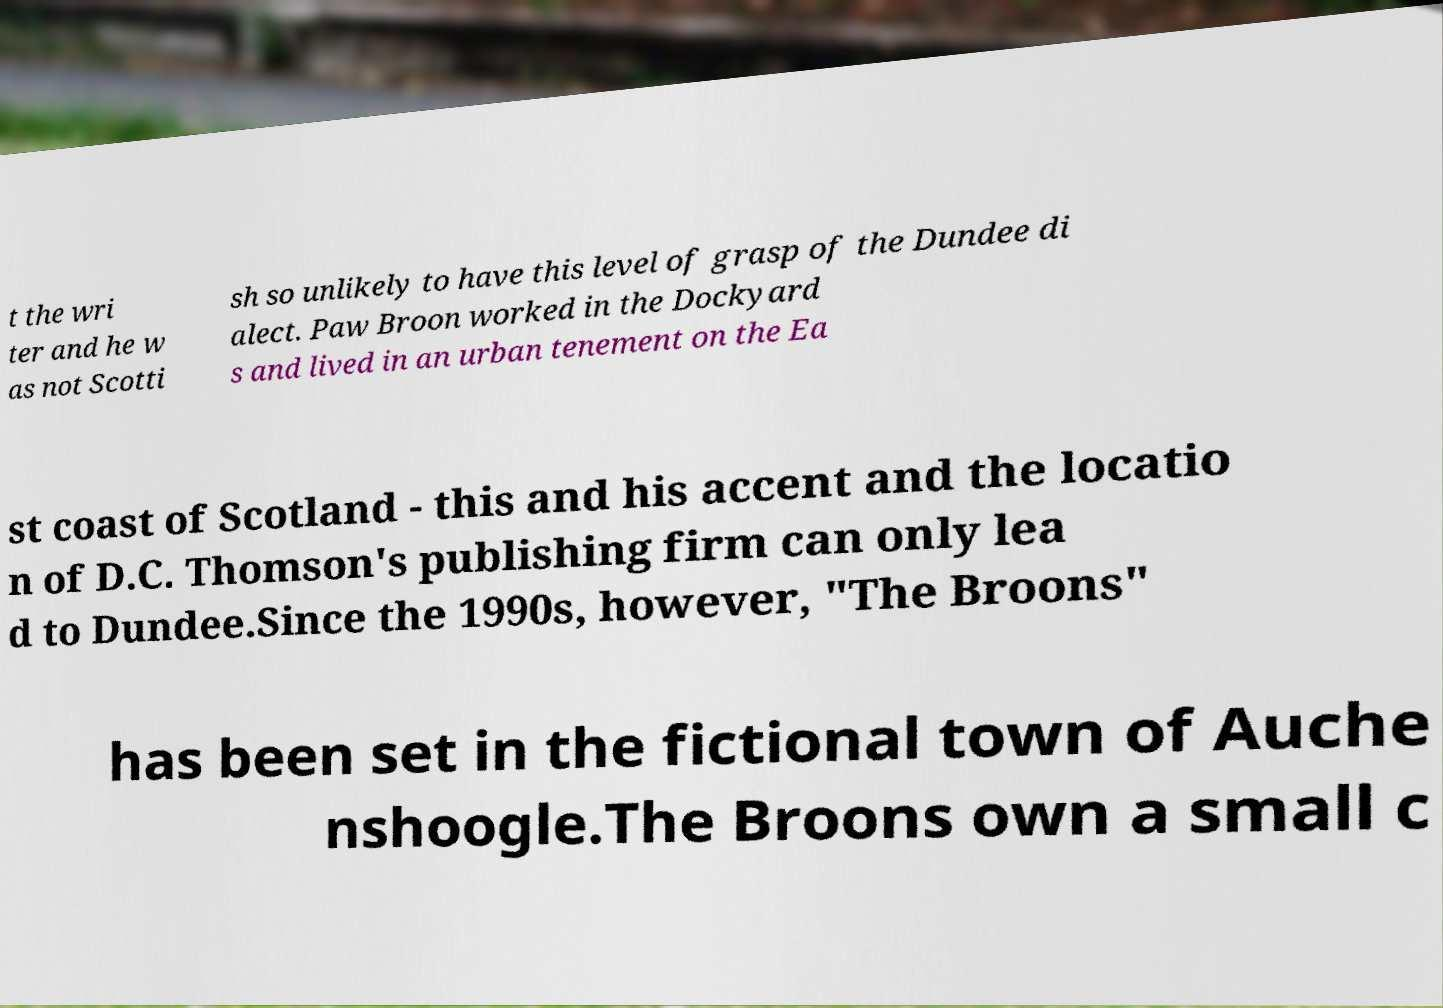What messages or text are displayed in this image? I need them in a readable, typed format. t the wri ter and he w as not Scotti sh so unlikely to have this level of grasp of the Dundee di alect. Paw Broon worked in the Dockyard s and lived in an urban tenement on the Ea st coast of Scotland - this and his accent and the locatio n of D.C. Thomson's publishing firm can only lea d to Dundee.Since the 1990s, however, "The Broons" has been set in the fictional town of Auche nshoogle.The Broons own a small c 